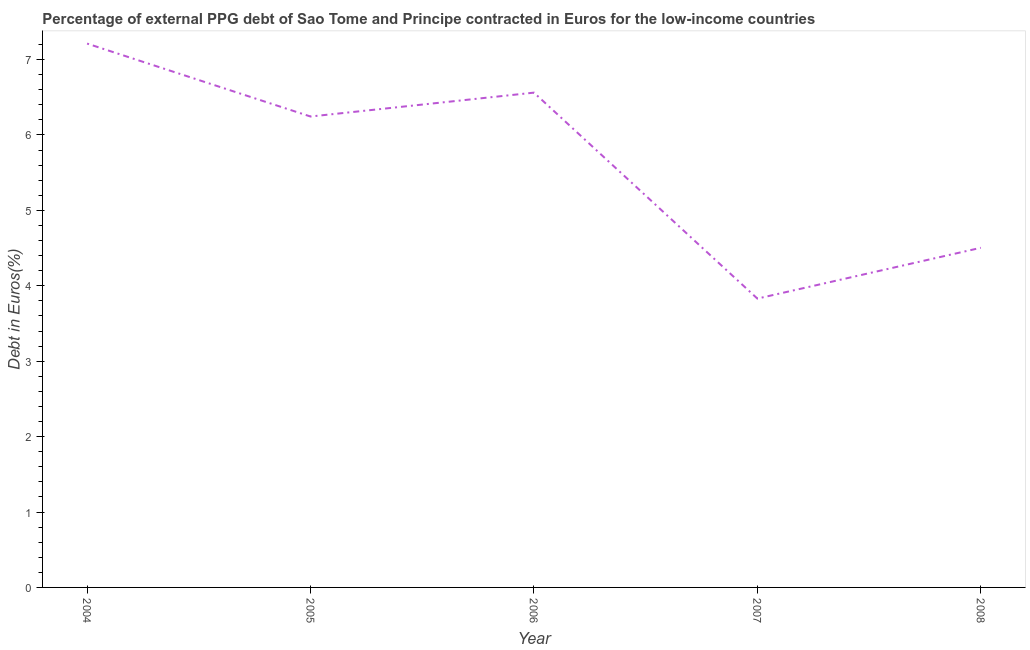What is the currency composition of ppg debt in 2008?
Give a very brief answer. 4.5. Across all years, what is the maximum currency composition of ppg debt?
Offer a very short reply. 7.21. Across all years, what is the minimum currency composition of ppg debt?
Ensure brevity in your answer.  3.83. In which year was the currency composition of ppg debt maximum?
Offer a terse response. 2004. In which year was the currency composition of ppg debt minimum?
Provide a succinct answer. 2007. What is the sum of the currency composition of ppg debt?
Provide a succinct answer. 28.35. What is the difference between the currency composition of ppg debt in 2004 and 2007?
Provide a succinct answer. 3.38. What is the average currency composition of ppg debt per year?
Your answer should be compact. 5.67. What is the median currency composition of ppg debt?
Provide a succinct answer. 6.24. What is the ratio of the currency composition of ppg debt in 2006 to that in 2007?
Give a very brief answer. 1.71. What is the difference between the highest and the second highest currency composition of ppg debt?
Offer a very short reply. 0.65. Is the sum of the currency composition of ppg debt in 2005 and 2008 greater than the maximum currency composition of ppg debt across all years?
Provide a short and direct response. Yes. What is the difference between the highest and the lowest currency composition of ppg debt?
Ensure brevity in your answer.  3.38. In how many years, is the currency composition of ppg debt greater than the average currency composition of ppg debt taken over all years?
Give a very brief answer. 3. How many years are there in the graph?
Offer a terse response. 5. What is the difference between two consecutive major ticks on the Y-axis?
Offer a very short reply. 1. Are the values on the major ticks of Y-axis written in scientific E-notation?
Offer a terse response. No. Does the graph contain grids?
Your answer should be compact. No. What is the title of the graph?
Your response must be concise. Percentage of external PPG debt of Sao Tome and Principe contracted in Euros for the low-income countries. What is the label or title of the Y-axis?
Your response must be concise. Debt in Euros(%). What is the Debt in Euros(%) in 2004?
Offer a very short reply. 7.21. What is the Debt in Euros(%) of 2005?
Your response must be concise. 6.24. What is the Debt in Euros(%) of 2006?
Your answer should be compact. 6.56. What is the Debt in Euros(%) in 2007?
Make the answer very short. 3.83. What is the Debt in Euros(%) of 2008?
Your answer should be compact. 4.5. What is the difference between the Debt in Euros(%) in 2004 and 2005?
Give a very brief answer. 0.97. What is the difference between the Debt in Euros(%) in 2004 and 2006?
Your answer should be compact. 0.65. What is the difference between the Debt in Euros(%) in 2004 and 2007?
Provide a succinct answer. 3.38. What is the difference between the Debt in Euros(%) in 2004 and 2008?
Offer a very short reply. 2.71. What is the difference between the Debt in Euros(%) in 2005 and 2006?
Ensure brevity in your answer.  -0.32. What is the difference between the Debt in Euros(%) in 2005 and 2007?
Offer a very short reply. 2.41. What is the difference between the Debt in Euros(%) in 2005 and 2008?
Your answer should be compact. 1.74. What is the difference between the Debt in Euros(%) in 2006 and 2007?
Give a very brief answer. 2.73. What is the difference between the Debt in Euros(%) in 2006 and 2008?
Your response must be concise. 2.06. What is the difference between the Debt in Euros(%) in 2007 and 2008?
Your response must be concise. -0.67. What is the ratio of the Debt in Euros(%) in 2004 to that in 2005?
Ensure brevity in your answer.  1.16. What is the ratio of the Debt in Euros(%) in 2004 to that in 2006?
Make the answer very short. 1.1. What is the ratio of the Debt in Euros(%) in 2004 to that in 2007?
Your answer should be very brief. 1.88. What is the ratio of the Debt in Euros(%) in 2004 to that in 2008?
Keep it short and to the point. 1.6. What is the ratio of the Debt in Euros(%) in 2005 to that in 2006?
Ensure brevity in your answer.  0.95. What is the ratio of the Debt in Euros(%) in 2005 to that in 2007?
Your response must be concise. 1.63. What is the ratio of the Debt in Euros(%) in 2005 to that in 2008?
Ensure brevity in your answer.  1.39. What is the ratio of the Debt in Euros(%) in 2006 to that in 2007?
Provide a succinct answer. 1.71. What is the ratio of the Debt in Euros(%) in 2006 to that in 2008?
Ensure brevity in your answer.  1.46. What is the ratio of the Debt in Euros(%) in 2007 to that in 2008?
Offer a very short reply. 0.85. 